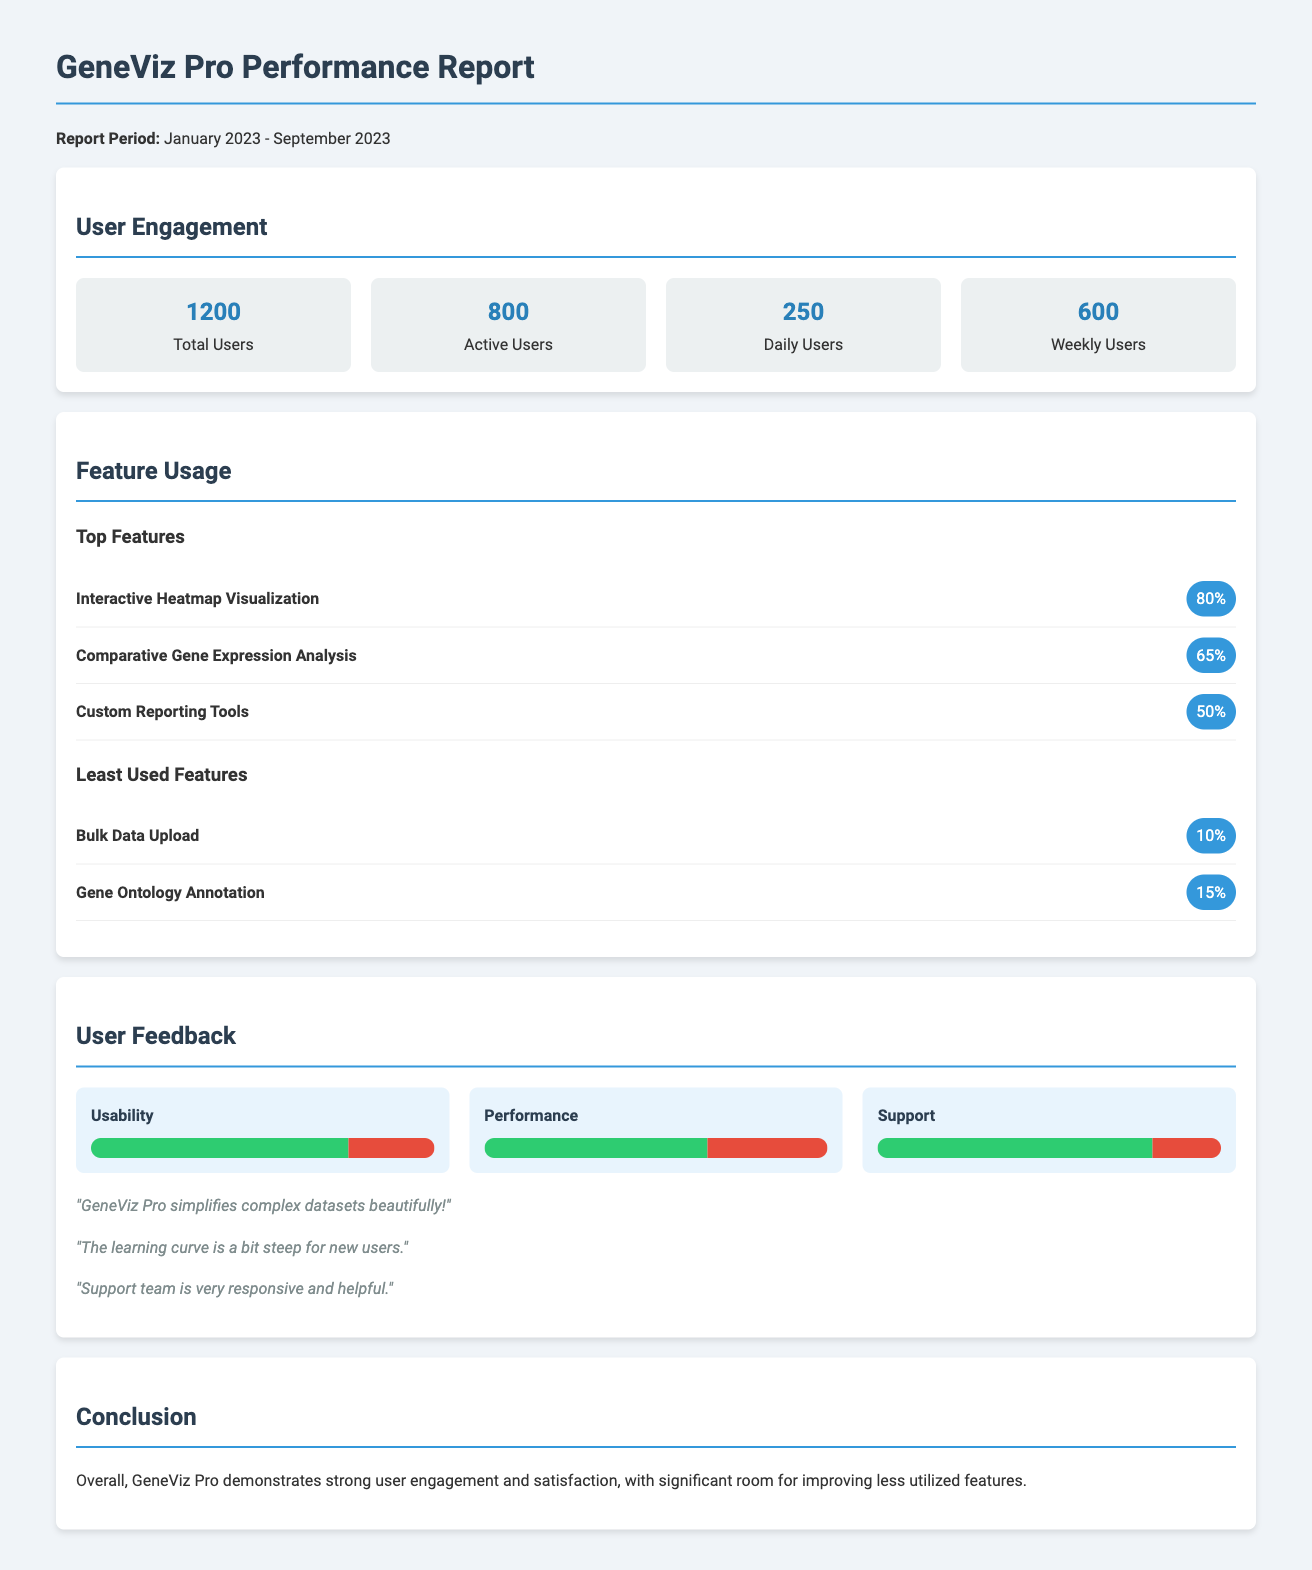what is the total number of users? The total number of users is provided in the User Engagement section of the document, which is 1200.
Answer: 1200 how many active users are there? The number of active users is listed as 800 in the User Engagement section.
Answer: 800 what is the percentage usage of the Interactive Heatmap Visualization feature? The usage percentage for the Interactive Heatmap Visualization feature is found in the Feature Usage section, which is 80%.
Answer: 80% what are the least used features? The least used features are detailed in the Feature Usage section; they are Bulk Data Upload and Gene Ontology Annotation, with usages of 10% and 15%, respectively.
Answer: Bulk Data Upload, Gene Ontology Annotation what is the usability feedback percentage? The usability feedback shows a positive score of 75% in the User Feedback section.
Answer: 75% how many user comments are provided? The document contains three user comments in the User Feedback section, which reflect user experiences.
Answer: 3 what period does the report cover? The report period stated in the document is from January 2023 to September 2023.
Answer: January 2023 - September 2023 which category received the highest positive feedback? The category with the highest positive feedback in the User Feedback section is Support, with a score of 80%.
Answer: Support what conclusion is drawn about GeneViz Pro? The document concludes that GeneViz Pro demonstrates strong user engagement and satisfaction.
Answer: Strong user engagement and satisfaction 